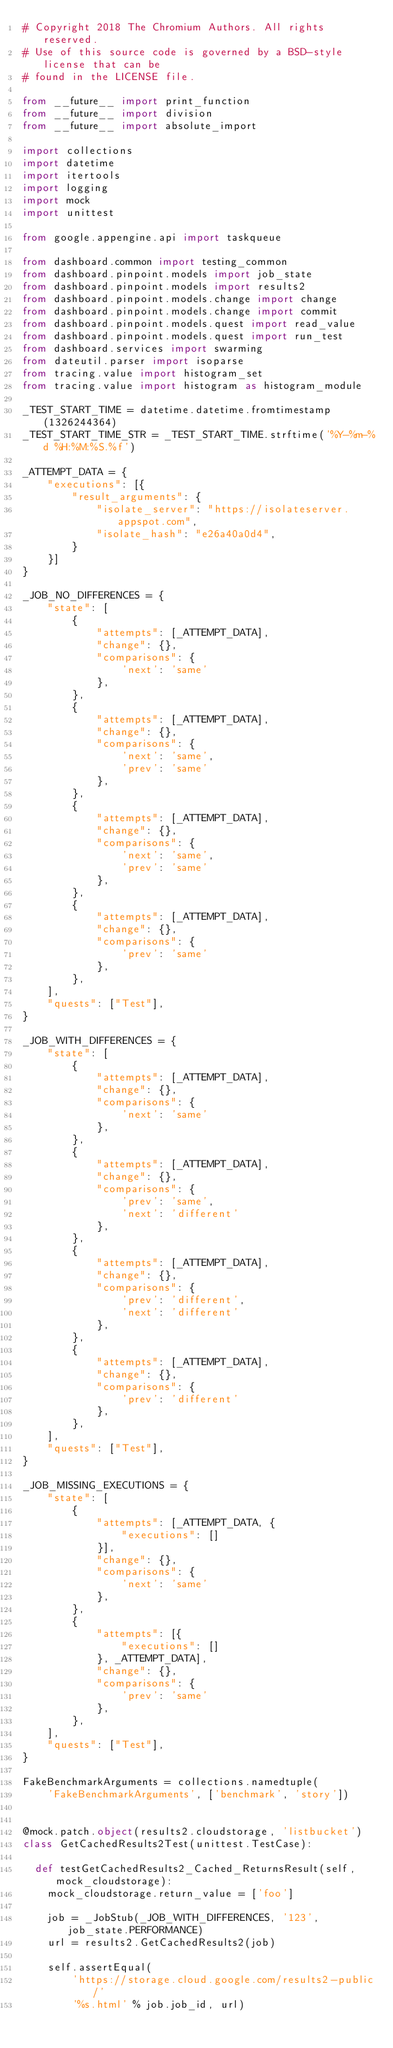Convert code to text. <code><loc_0><loc_0><loc_500><loc_500><_Python_># Copyright 2018 The Chromium Authors. All rights reserved.
# Use of this source code is governed by a BSD-style license that can be
# found in the LICENSE file.

from __future__ import print_function
from __future__ import division
from __future__ import absolute_import

import collections
import datetime
import itertools
import logging
import mock
import unittest

from google.appengine.api import taskqueue

from dashboard.common import testing_common
from dashboard.pinpoint.models import job_state
from dashboard.pinpoint.models import results2
from dashboard.pinpoint.models.change import change
from dashboard.pinpoint.models.change import commit
from dashboard.pinpoint.models.quest import read_value
from dashboard.pinpoint.models.quest import run_test
from dashboard.services import swarming
from dateutil.parser import isoparse
from tracing.value import histogram_set
from tracing.value import histogram as histogram_module

_TEST_START_TIME = datetime.datetime.fromtimestamp(1326244364)
_TEST_START_TIME_STR = _TEST_START_TIME.strftime('%Y-%m-%d %H:%M:%S.%f')

_ATTEMPT_DATA = {
    "executions": [{
        "result_arguments": {
            "isolate_server": "https://isolateserver.appspot.com",
            "isolate_hash": "e26a40a0d4",
        }
    }]
}

_JOB_NO_DIFFERENCES = {
    "state": [
        {
            "attempts": [_ATTEMPT_DATA],
            "change": {},
            "comparisons": {
                'next': 'same'
            },
        },
        {
            "attempts": [_ATTEMPT_DATA],
            "change": {},
            "comparisons": {
                'next': 'same',
                'prev': 'same'
            },
        },
        {
            "attempts": [_ATTEMPT_DATA],
            "change": {},
            "comparisons": {
                'next': 'same',
                'prev': 'same'
            },
        },
        {
            "attempts": [_ATTEMPT_DATA],
            "change": {},
            "comparisons": {
                'prev': 'same'
            },
        },
    ],
    "quests": ["Test"],
}

_JOB_WITH_DIFFERENCES = {
    "state": [
        {
            "attempts": [_ATTEMPT_DATA],
            "change": {},
            "comparisons": {
                'next': 'same'
            },
        },
        {
            "attempts": [_ATTEMPT_DATA],
            "change": {},
            "comparisons": {
                'prev': 'same',
                'next': 'different'
            },
        },
        {
            "attempts": [_ATTEMPT_DATA],
            "change": {},
            "comparisons": {
                'prev': 'different',
                'next': 'different'
            },
        },
        {
            "attempts": [_ATTEMPT_DATA],
            "change": {},
            "comparisons": {
                'prev': 'different'
            },
        },
    ],
    "quests": ["Test"],
}

_JOB_MISSING_EXECUTIONS = {
    "state": [
        {
            "attempts": [_ATTEMPT_DATA, {
                "executions": []
            }],
            "change": {},
            "comparisons": {
                'next': 'same'
            },
        },
        {
            "attempts": [{
                "executions": []
            }, _ATTEMPT_DATA],
            "change": {},
            "comparisons": {
                'prev': 'same'
            },
        },
    ],
    "quests": ["Test"],
}

FakeBenchmarkArguments = collections.namedtuple(
    'FakeBenchmarkArguments', ['benchmark', 'story'])


@mock.patch.object(results2.cloudstorage, 'listbucket')
class GetCachedResults2Test(unittest.TestCase):

  def testGetCachedResults2_Cached_ReturnsResult(self, mock_cloudstorage):
    mock_cloudstorage.return_value = ['foo']

    job = _JobStub(_JOB_WITH_DIFFERENCES, '123', job_state.PERFORMANCE)
    url = results2.GetCachedResults2(job)

    self.assertEqual(
        'https://storage.cloud.google.com/results2-public/'
        '%s.html' % job.job_id, url)
</code> 